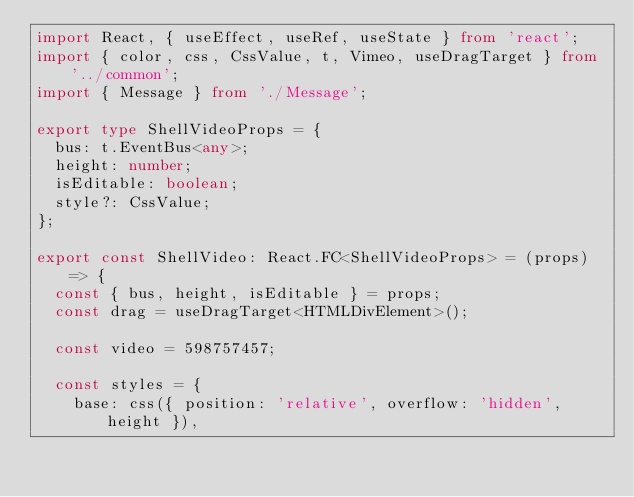Convert code to text. <code><loc_0><loc_0><loc_500><loc_500><_TypeScript_>import React, { useEffect, useRef, useState } from 'react';
import { color, css, CssValue, t, Vimeo, useDragTarget } from '../common';
import { Message } from './Message';

export type ShellVideoProps = {
  bus: t.EventBus<any>;
  height: number;
  isEditable: boolean;
  style?: CssValue;
};

export const ShellVideo: React.FC<ShellVideoProps> = (props) => {
  const { bus, height, isEditable } = props;
  const drag = useDragTarget<HTMLDivElement>();

  const video = 598757457;

  const styles = {
    base: css({ position: 'relative', overflow: 'hidden', height }),</code> 